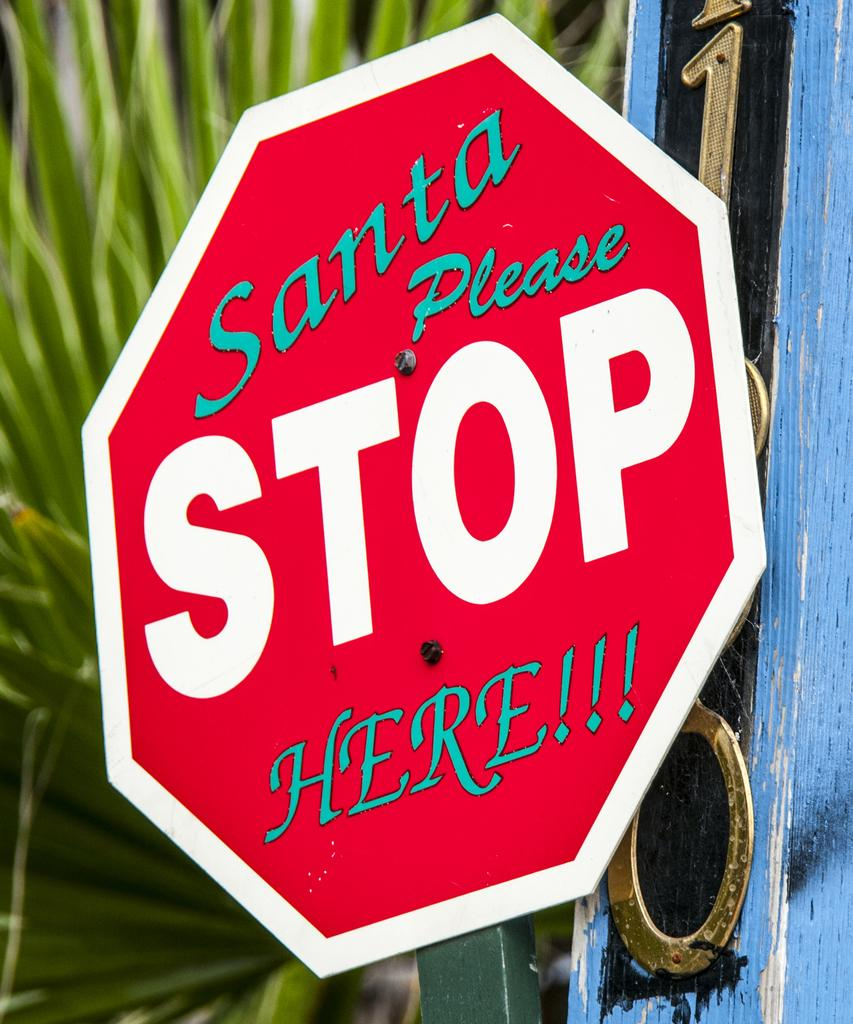<image>
Render a clear and concise summary of the photo. Someone added "Santa please" and "here" to a stop sign to make it humorous. 